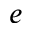<formula> <loc_0><loc_0><loc_500><loc_500>e</formula> 